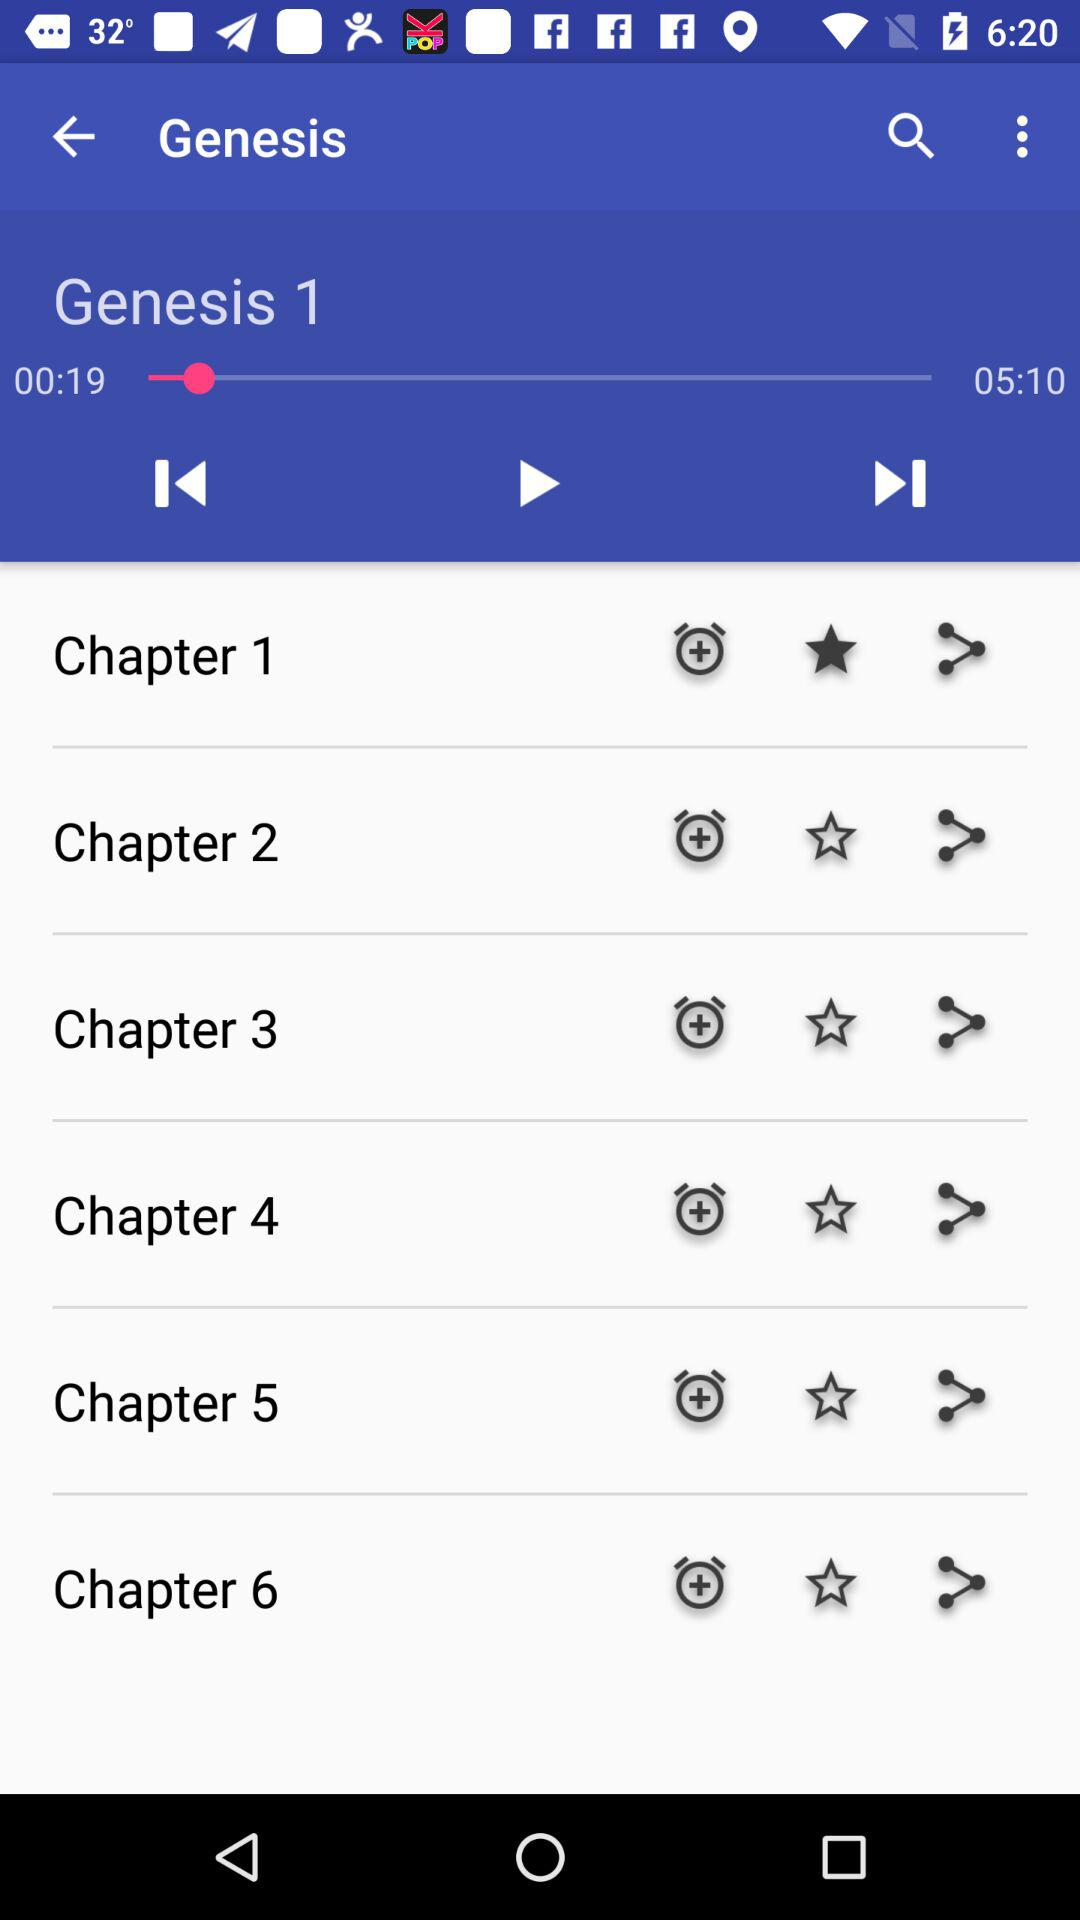How many chapters are there in the book?
Answer the question using a single word or phrase. 6 